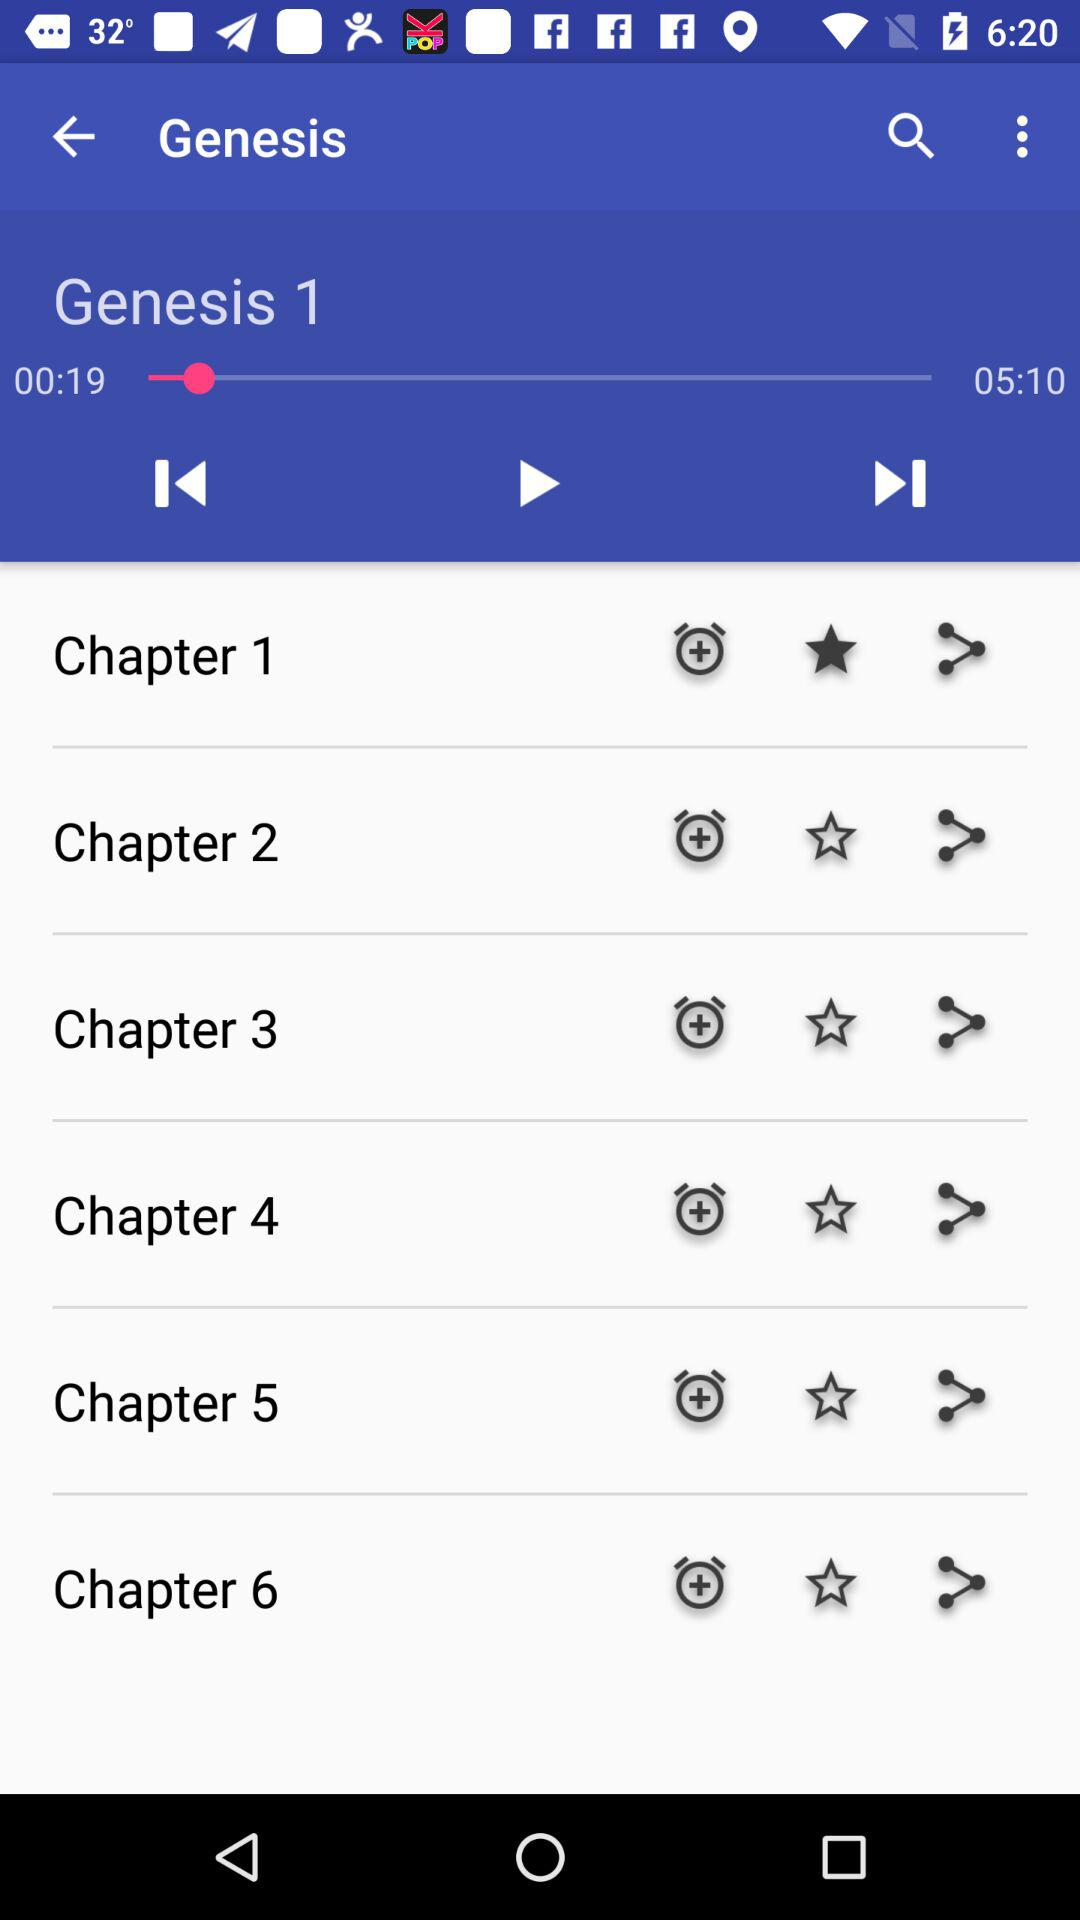How many chapters are there in the book?
Answer the question using a single word or phrase. 6 